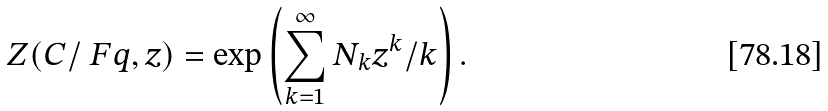Convert formula to latex. <formula><loc_0><loc_0><loc_500><loc_500>Z ( C / \ F q , z ) = \exp \left ( \sum _ { k = 1 } ^ { \infty } N _ { k } z ^ { k } / k \right ) .</formula> 